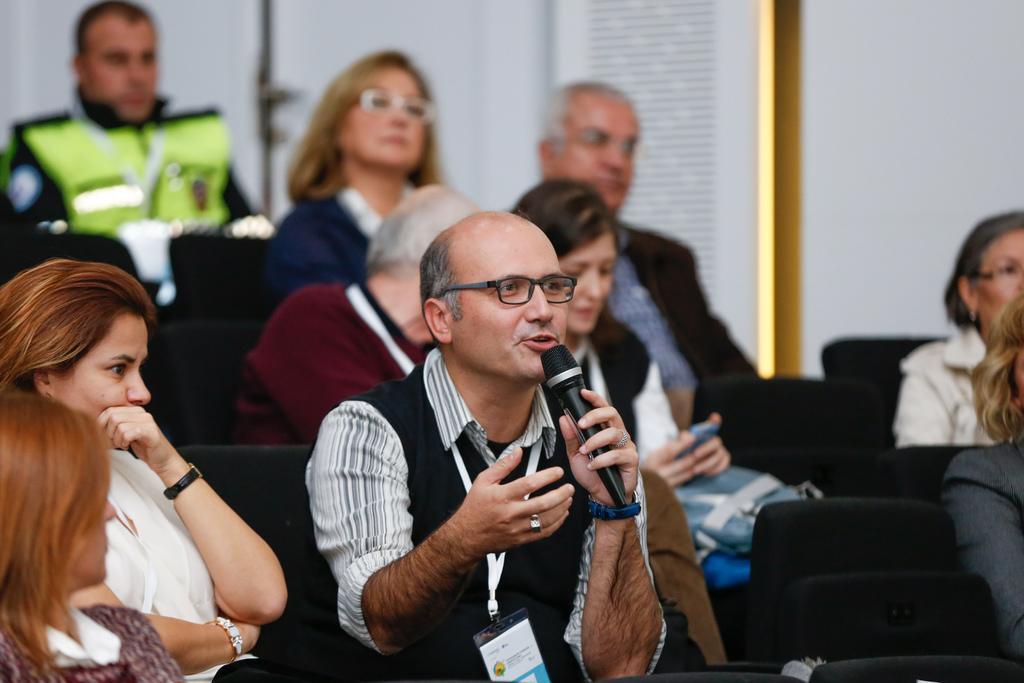How would you summarize this image in a sentence or two? In this picture, there are group of people sitting on the seats. At the bottom, there is a man holding a mike and he is wearing a black jacket. Beside him, there are two women. On the top, there are people. 